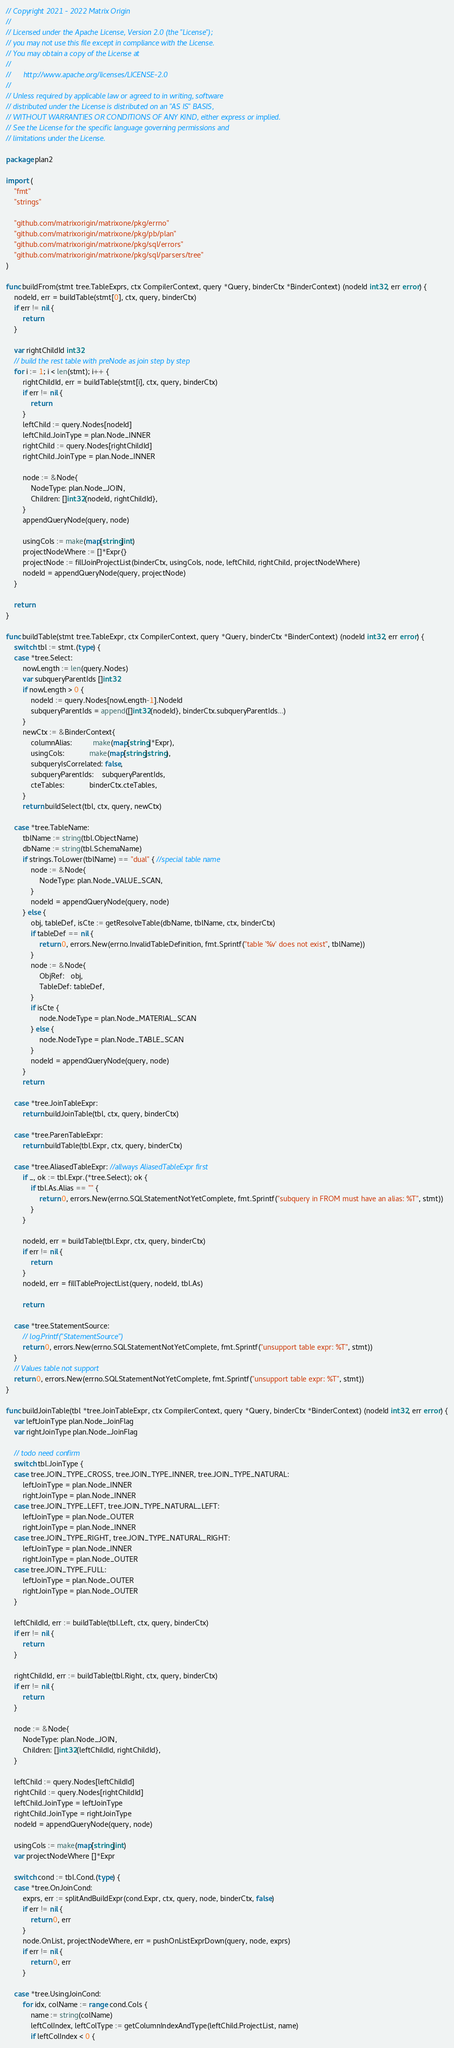Convert code to text. <code><loc_0><loc_0><loc_500><loc_500><_Go_>// Copyright 2021 - 2022 Matrix Origin
//
// Licensed under the Apache License, Version 2.0 (the "License");
// you may not use this file except in compliance with the License.
// You may obtain a copy of the License at
//
//      http://www.apache.org/licenses/LICENSE-2.0
//
// Unless required by applicable law or agreed to in writing, software
// distributed under the License is distributed on an "AS IS" BASIS,
// WITHOUT WARRANTIES OR CONDITIONS OF ANY KIND, either express or implied.
// See the License for the specific language governing permissions and
// limitations under the License.

package plan2

import (
	"fmt"
	"strings"

	"github.com/matrixorigin/matrixone/pkg/errno"
	"github.com/matrixorigin/matrixone/pkg/pb/plan"
	"github.com/matrixorigin/matrixone/pkg/sql/errors"
	"github.com/matrixorigin/matrixone/pkg/sql/parsers/tree"
)

func buildFrom(stmt tree.TableExprs, ctx CompilerContext, query *Query, binderCtx *BinderContext) (nodeId int32, err error) {
	nodeId, err = buildTable(stmt[0], ctx, query, binderCtx)
	if err != nil {
		return
	}

	var rightChildId int32
	// build the rest table with preNode as join step by step
	for i := 1; i < len(stmt); i++ {
		rightChildId, err = buildTable(stmt[i], ctx, query, binderCtx)
		if err != nil {
			return
		}
		leftChild := query.Nodes[nodeId]
		leftChild.JoinType = plan.Node_INNER
		rightChild := query.Nodes[rightChildId]
		rightChild.JoinType = plan.Node_INNER

		node := &Node{
			NodeType: plan.Node_JOIN,
			Children: []int32{nodeId, rightChildId},
		}
		appendQueryNode(query, node)

		usingCols := make(map[string]int)
		projectNodeWhere := []*Expr{}
		projectNode := fillJoinProjectList(binderCtx, usingCols, node, leftChild, rightChild, projectNodeWhere)
		nodeId = appendQueryNode(query, projectNode)
	}

	return
}

func buildTable(stmt tree.TableExpr, ctx CompilerContext, query *Query, binderCtx *BinderContext) (nodeId int32, err error) {
	switch tbl := stmt.(type) {
	case *tree.Select:
		nowLength := len(query.Nodes)
		var subqueryParentIds []int32
		if nowLength > 0 {
			nodeId := query.Nodes[nowLength-1].NodeId
			subqueryParentIds = append([]int32{nodeId}, binderCtx.subqueryParentIds...)
		}
		newCtx := &BinderContext{
			columnAlias:          make(map[string]*Expr),
			usingCols:            make(map[string]string),
			subqueryIsCorrelated: false,
			subqueryParentIds:    subqueryParentIds,
			cteTables:            binderCtx.cteTables,
		}
		return buildSelect(tbl, ctx, query, newCtx)

	case *tree.TableName:
		tblName := string(tbl.ObjectName)
		dbName := string(tbl.SchemaName)
		if strings.ToLower(tblName) == "dual" { //special table name
			node := &Node{
				NodeType: plan.Node_VALUE_SCAN,
			}
			nodeId = appendQueryNode(query, node)
		} else {
			obj, tableDef, isCte := getResolveTable(dbName, tblName, ctx, binderCtx)
			if tableDef == nil {
				return 0, errors.New(errno.InvalidTableDefinition, fmt.Sprintf("table '%v' does not exist", tblName))
			}
			node := &Node{
				ObjRef:   obj,
				TableDef: tableDef,
			}
			if isCte {
				node.NodeType = plan.Node_MATERIAL_SCAN
			} else {
				node.NodeType = plan.Node_TABLE_SCAN
			}
			nodeId = appendQueryNode(query, node)
		}
		return

	case *tree.JoinTableExpr:
		return buildJoinTable(tbl, ctx, query, binderCtx)

	case *tree.ParenTableExpr:
		return buildTable(tbl.Expr, ctx, query, binderCtx)

	case *tree.AliasedTableExpr: //allways AliasedTableExpr first
		if _, ok := tbl.Expr.(*tree.Select); ok {
			if tbl.As.Alias == "" {
				return 0, errors.New(errno.SQLStatementNotYetComplete, fmt.Sprintf("subquery in FROM must have an alias: %T", stmt))
			}
		}

		nodeId, err = buildTable(tbl.Expr, ctx, query, binderCtx)
		if err != nil {
			return
		}
		nodeId, err = fillTableProjectList(query, nodeId, tbl.As)

		return

	case *tree.StatementSource:
		// log.Printf("StatementSource")
		return 0, errors.New(errno.SQLStatementNotYetComplete, fmt.Sprintf("unsupport table expr: %T", stmt))
	}
	// Values table not support
	return 0, errors.New(errno.SQLStatementNotYetComplete, fmt.Sprintf("unsupport table expr: %T", stmt))
}

func buildJoinTable(tbl *tree.JoinTableExpr, ctx CompilerContext, query *Query, binderCtx *BinderContext) (nodeId int32, err error) {
	var leftJoinType plan.Node_JoinFlag
	var rightJoinType plan.Node_JoinFlag

	// todo need confirm
	switch tbl.JoinType {
	case tree.JOIN_TYPE_CROSS, tree.JOIN_TYPE_INNER, tree.JOIN_TYPE_NATURAL:
		leftJoinType = plan.Node_INNER
		rightJoinType = plan.Node_INNER
	case tree.JOIN_TYPE_LEFT, tree.JOIN_TYPE_NATURAL_LEFT:
		leftJoinType = plan.Node_OUTER
		rightJoinType = plan.Node_INNER
	case tree.JOIN_TYPE_RIGHT, tree.JOIN_TYPE_NATURAL_RIGHT:
		leftJoinType = plan.Node_INNER
		rightJoinType = plan.Node_OUTER
	case tree.JOIN_TYPE_FULL:
		leftJoinType = plan.Node_OUTER
		rightJoinType = plan.Node_OUTER
	}

	leftChildId, err := buildTable(tbl.Left, ctx, query, binderCtx)
	if err != nil {
		return
	}

	rightChildId, err := buildTable(tbl.Right, ctx, query, binderCtx)
	if err != nil {
		return
	}

	node := &Node{
		NodeType: plan.Node_JOIN,
		Children: []int32{leftChildId, rightChildId},
	}

	leftChild := query.Nodes[leftChildId]
	rightChild := query.Nodes[rightChildId]
	leftChild.JoinType = leftJoinType
	rightChild.JoinType = rightJoinType
	nodeId = appendQueryNode(query, node)

	usingCols := make(map[string]int)
	var projectNodeWhere []*Expr

	switch cond := tbl.Cond.(type) {
	case *tree.OnJoinCond:
		exprs, err := splitAndBuildExpr(cond.Expr, ctx, query, node, binderCtx, false)
		if err != nil {
			return 0, err
		}
		node.OnList, projectNodeWhere, err = pushOnListExprDown(query, node, exprs)
		if err != nil {
			return 0, err
		}

	case *tree.UsingJoinCond:
		for idx, colName := range cond.Cols {
			name := string(colName)
			leftColIndex, leftColType := getColumnIndexAndType(leftChild.ProjectList, name)
			if leftColIndex < 0 {</code> 